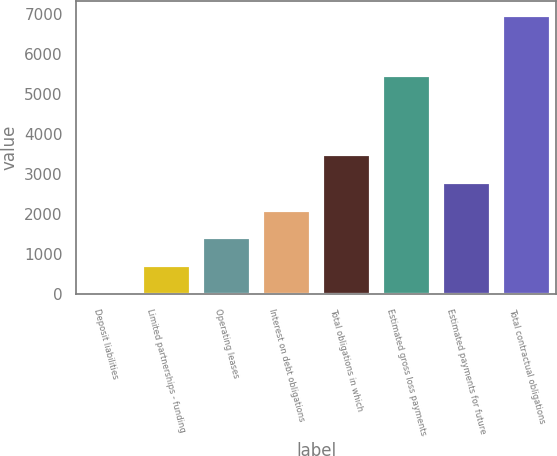Convert chart. <chart><loc_0><loc_0><loc_500><loc_500><bar_chart><fcel>Deposit liabilities<fcel>Limited partnerships - funding<fcel>Operating leases<fcel>Interest on debt obligations<fcel>Total obligations in which<fcel>Estimated gross loss payments<fcel>Estimated payments for future<fcel>Total contractual obligations<nl><fcel>30<fcel>724.9<fcel>1419.8<fcel>2114.7<fcel>3504.5<fcel>5493<fcel>2809.6<fcel>6979<nl></chart> 